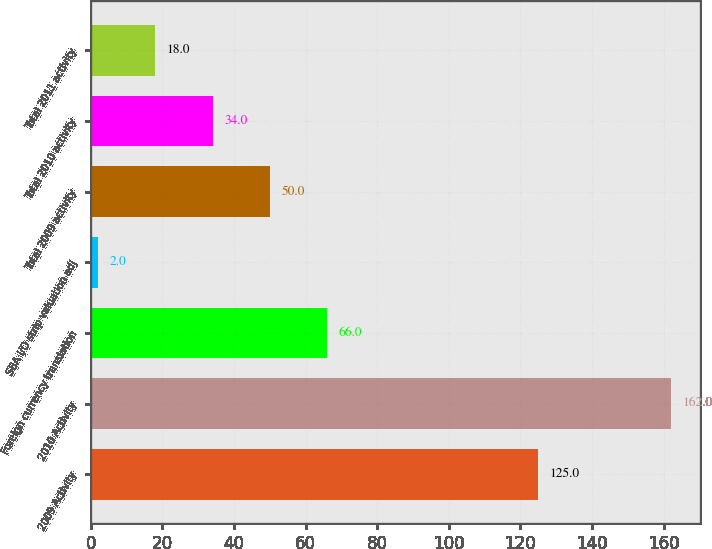Convert chart. <chart><loc_0><loc_0><loc_500><loc_500><bar_chart><fcel>2009 Activity<fcel>2010 Activity<fcel>Foreign currency translation<fcel>SBA I/O strip valuation adj<fcel>Total 2009 activity<fcel>Total 2010 activity<fcel>Total 2011 activity<nl><fcel>125<fcel>162<fcel>66<fcel>2<fcel>50<fcel>34<fcel>18<nl></chart> 